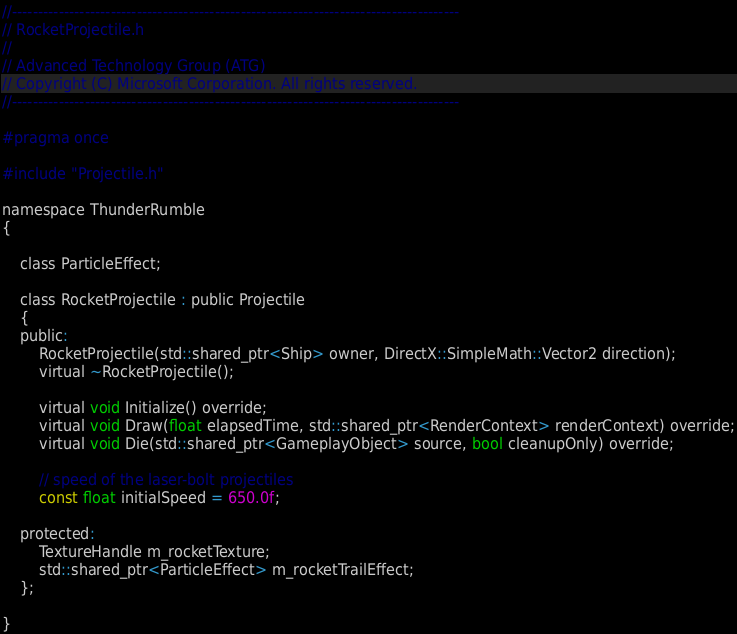Convert code to text. <code><loc_0><loc_0><loc_500><loc_500><_C_>//--------------------------------------------------------------------------------------
// RocketProjectile.h
//
// Advanced Technology Group (ATG)
// Copyright (C) Microsoft Corporation. All rights reserved.
//--------------------------------------------------------------------------------------

#pragma once

#include "Projectile.h"

namespace ThunderRumble
{

    class ParticleEffect;

    class RocketProjectile : public Projectile
    {
    public:
        RocketProjectile(std::shared_ptr<Ship> owner, DirectX::SimpleMath::Vector2 direction);
        virtual ~RocketProjectile();

        virtual void Initialize() override;
        virtual void Draw(float elapsedTime, std::shared_ptr<RenderContext> renderContext) override;
        virtual void Die(std::shared_ptr<GameplayObject> source, bool cleanupOnly) override;

        // speed of the laser-bolt projectiles
        const float initialSpeed = 650.0f;

    protected:
        TextureHandle m_rocketTexture;
        std::shared_ptr<ParticleEffect> m_rocketTrailEffect;
    };

}
</code> 